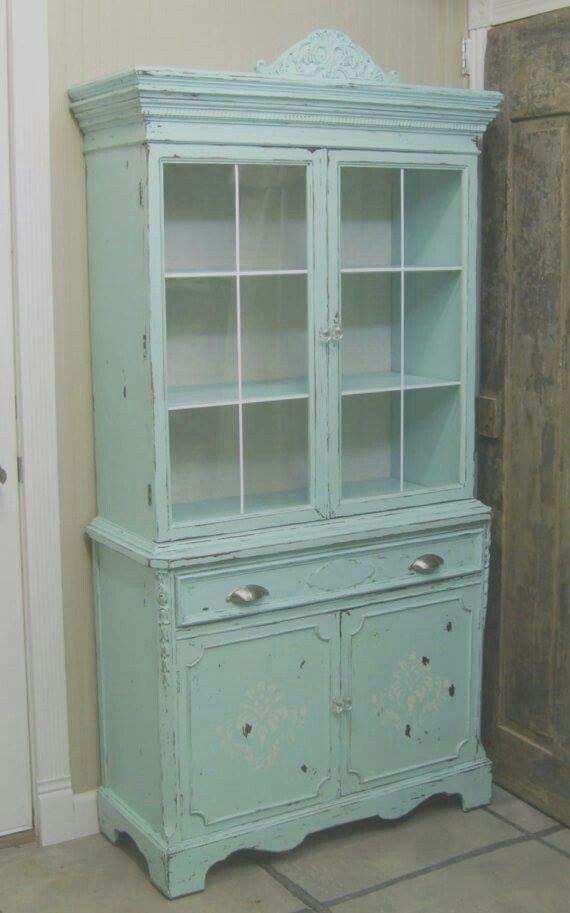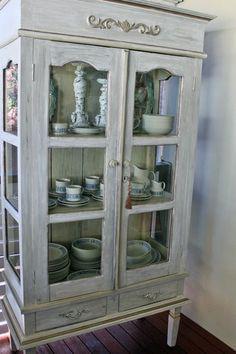The first image is the image on the left, the second image is the image on the right. For the images displayed, is the sentence "One image shows a pale blue shabby chic cabinet with a shaped element on top and a two-handled drawer under the glass doors." factually correct? Answer yes or no. Yes. The first image is the image on the left, the second image is the image on the right. Examine the images to the left and right. Is the description "A wooded hutch with a curved top stands on feet, while a second hutch has a straight top and sits flush to the floor." accurate? Answer yes or no. No. 